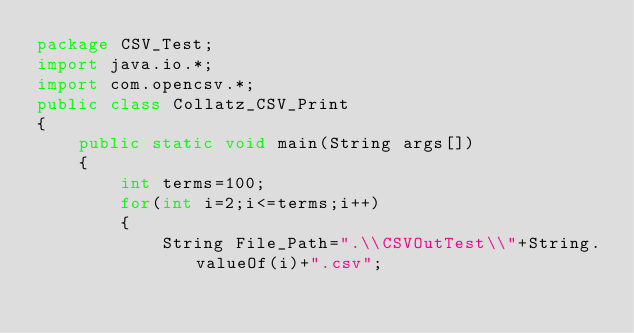<code> <loc_0><loc_0><loc_500><loc_500><_Java_>package CSV_Test;
import java.io.*;
import com.opencsv.*;
public class Collatz_CSV_Print
{
	public static void main(String args[])
	{
		int terms=100;
		for(int i=2;i<=terms;i++)
		{
			String File_Path=".\\CSVOutTest\\"+String.valueOf(i)+".csv";</code> 